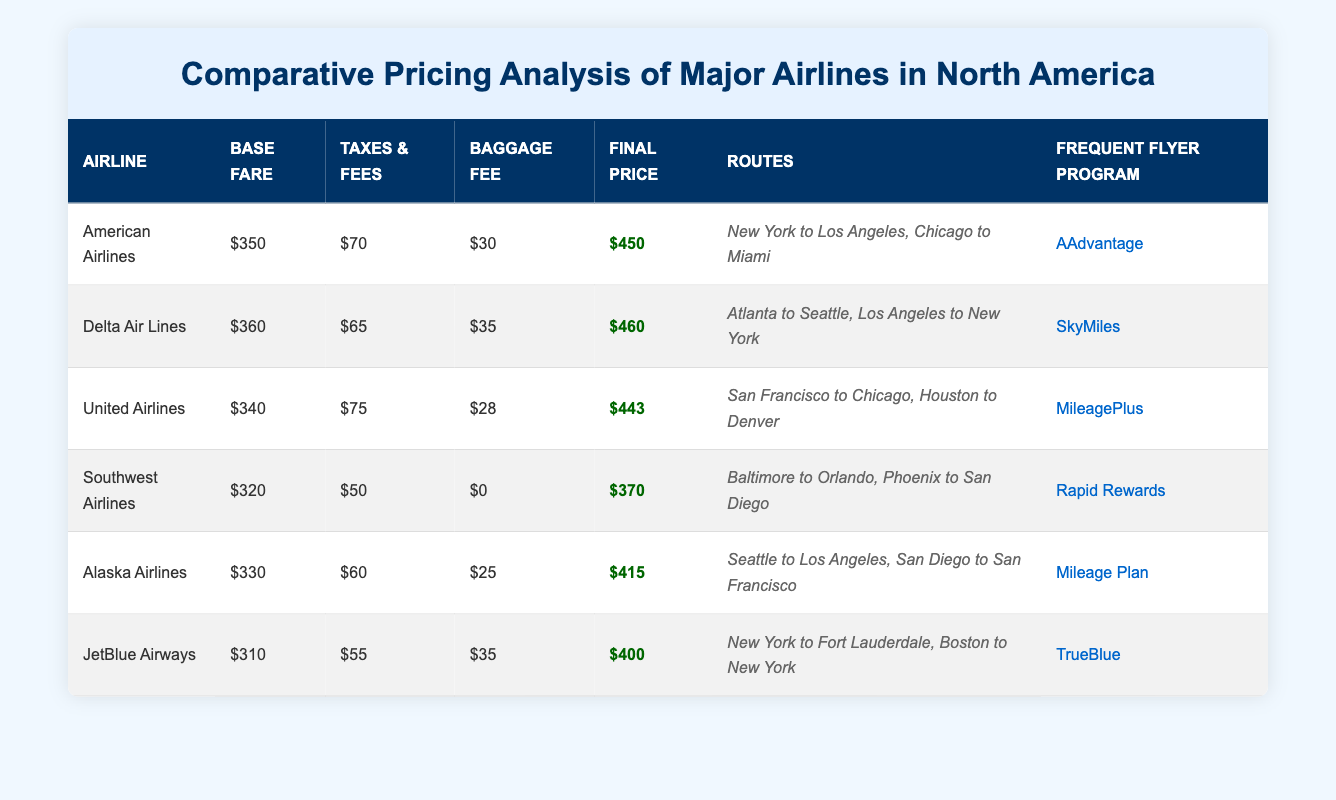What is the final price for Southwest Airlines? The final price for Southwest Airlines is directly listed in the table under the 'Final Price' column.
Answer: 370 Which airline has the highest base fare? Comparing the base fare values for each airline listed, Delta Air Lines has the highest base fare at $360.
Answer: Delta Air Lines What is the total of base fares for all airlines combined? Summing the base fares: 350 + 360 + 340 + 320 + 330 + 310 = 2010. The total of base fares for all airlines is $2010.
Answer: 2010 Is the baggage fee for Alaska Airlines higher than that of JetBlue Airways? The baggage fee for Alaska Airlines is $25, while JetBlue Airways has a baggage fee of $35. Since $25 is less than $35, the statement is false.
Answer: No What is the average final price across all airlines? Calculating the average final price: sum of final prices is 450 + 460 + 443 + 370 + 415 + 400 = 2538. There are 6 airlines, so the average is 2538/6 = 423.
Answer: 423 Which airline has the lowest final price, and what is that price? Looking through the 'Final Price' column, Southwest Airlines has the lowest final price at $370.
Answer: Southwest Airlines, 370 Does American Airlines offer a frequent flyer program? Yes, American Airlines has a frequent flyer program called AAdvantage, as mentioned in the table.
Answer: Yes What is the difference in final price between the highest and lowest priced airlines? The highest final price is for Delta Air Lines at $460, and the lowest is for Southwest Airlines at $370. The difference is 460 - 370 = 90.
Answer: 90 What are the two routes offered by JetBlue Airways? The routes listed for JetBlue Airways are "New York to Fort Lauderdale" and "Boston to New York", found under the 'Routes' column.
Answer: New York to Fort Lauderdale, Boston to New York 